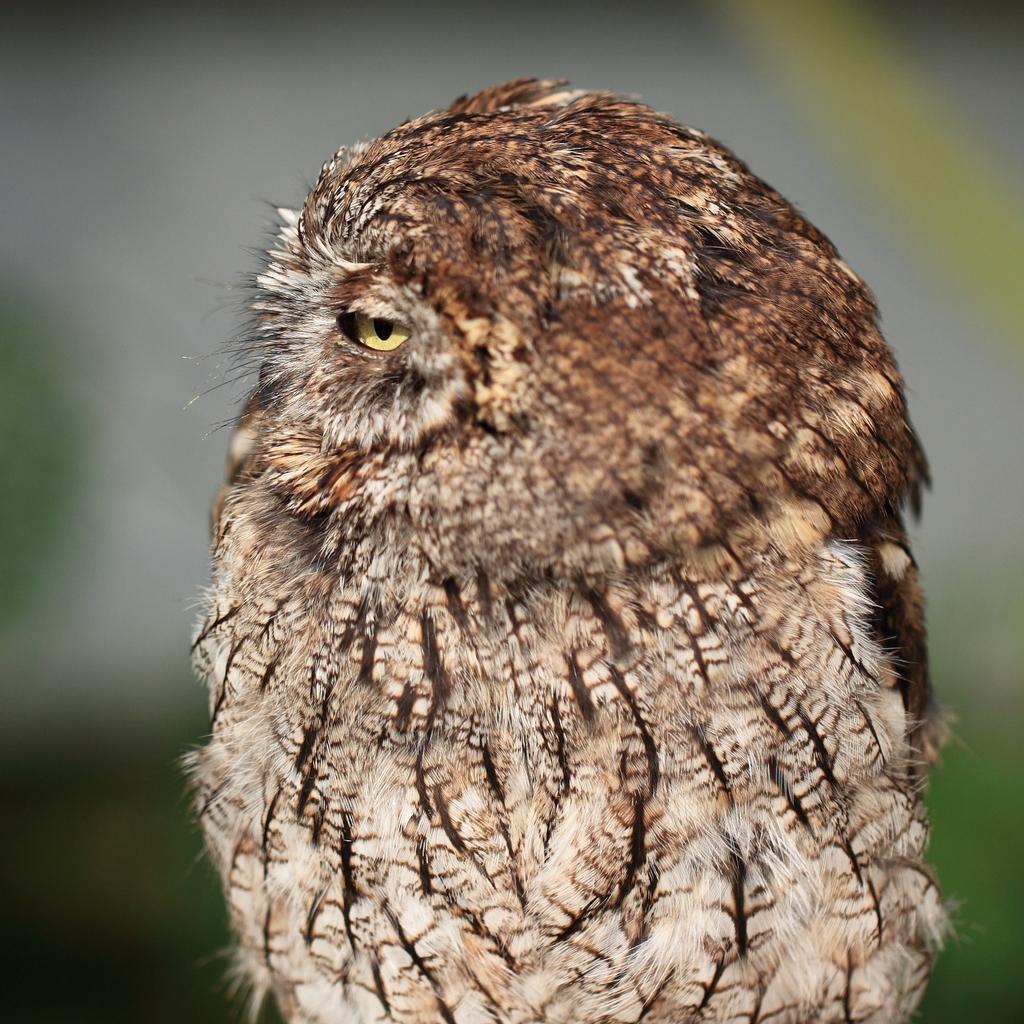Please provide a concise description of this image. In this image we can see an owl and we can also see the blurred background. 